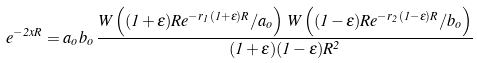<formula> <loc_0><loc_0><loc_500><loc_500>e ^ { - 2 x R } = a _ { o } b _ { o } \, \frac { W \left ( ( 1 + \epsilon ) R e ^ { - r _ { 1 } ( 1 + \epsilon ) R } / a _ { o } \right ) \, W \left ( ( 1 - \epsilon ) R e ^ { - r _ { 2 } ( 1 - \epsilon ) R } / b _ { o } \right ) } { ( 1 + \epsilon ) ( 1 - \epsilon ) R ^ { 2 } }</formula> 